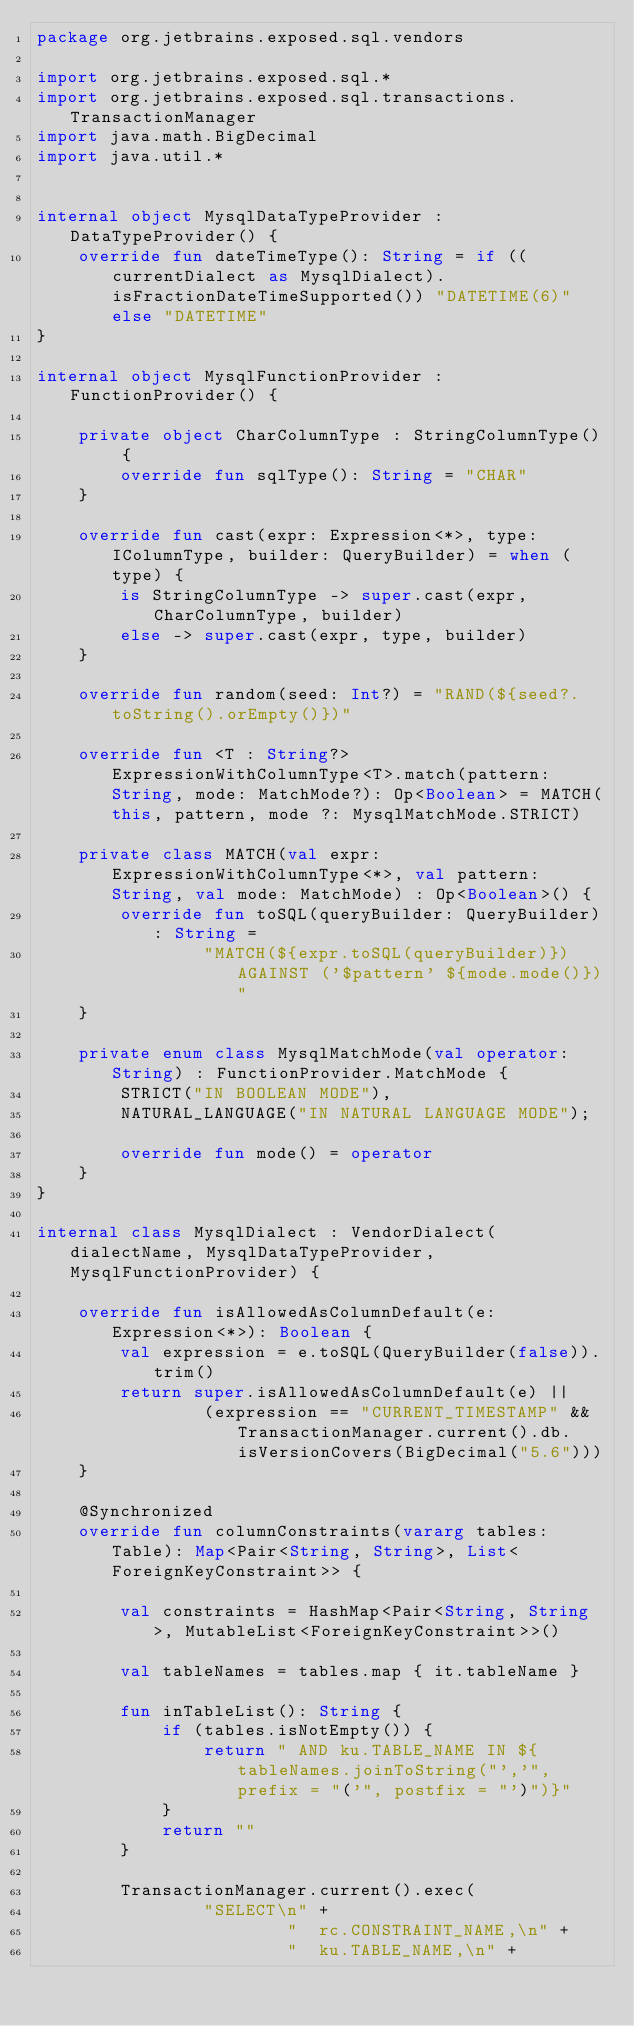<code> <loc_0><loc_0><loc_500><loc_500><_Kotlin_>package org.jetbrains.exposed.sql.vendors

import org.jetbrains.exposed.sql.*
import org.jetbrains.exposed.sql.transactions.TransactionManager
import java.math.BigDecimal
import java.util.*


internal object MysqlDataTypeProvider : DataTypeProvider() {
    override fun dateTimeType(): String = if ((currentDialect as MysqlDialect).isFractionDateTimeSupported()) "DATETIME(6)" else "DATETIME"
}

internal object MysqlFunctionProvider : FunctionProvider() {

    private object CharColumnType : StringColumnType() {
        override fun sqlType(): String = "CHAR"
    }

    override fun cast(expr: Expression<*>, type: IColumnType, builder: QueryBuilder) = when (type) {
        is StringColumnType -> super.cast(expr, CharColumnType, builder)
        else -> super.cast(expr, type, builder)
    }

    override fun random(seed: Int?) = "RAND(${seed?.toString().orEmpty()})"

    override fun <T : String?> ExpressionWithColumnType<T>.match(pattern: String, mode: MatchMode?): Op<Boolean> = MATCH(this, pattern, mode ?: MysqlMatchMode.STRICT)

    private class MATCH(val expr: ExpressionWithColumnType<*>, val pattern: String, val mode: MatchMode) : Op<Boolean>() {
        override fun toSQL(queryBuilder: QueryBuilder): String =
                "MATCH(${expr.toSQL(queryBuilder)}) AGAINST ('$pattern' ${mode.mode()})"
    }

    private enum class MysqlMatchMode(val operator: String) : FunctionProvider.MatchMode {
        STRICT("IN BOOLEAN MODE"),
        NATURAL_LANGUAGE("IN NATURAL LANGUAGE MODE");

        override fun mode() = operator
    }
}

internal class MysqlDialect : VendorDialect(dialectName, MysqlDataTypeProvider, MysqlFunctionProvider) {

    override fun isAllowedAsColumnDefault(e: Expression<*>): Boolean {
        val expression = e.toSQL(QueryBuilder(false)).trim()
        return super.isAllowedAsColumnDefault(e) ||
                (expression == "CURRENT_TIMESTAMP" && TransactionManager.current().db.isVersionCovers(BigDecimal("5.6")))
    }

    @Synchronized
    override fun columnConstraints(vararg tables: Table): Map<Pair<String, String>, List<ForeignKeyConstraint>> {

        val constraints = HashMap<Pair<String, String>, MutableList<ForeignKeyConstraint>>()

        val tableNames = tables.map { it.tableName }

        fun inTableList(): String {
            if (tables.isNotEmpty()) {
                return " AND ku.TABLE_NAME IN ${tableNames.joinToString("','", prefix = "('", postfix = "')")}"
            }
            return ""
        }

        TransactionManager.current().exec(
                "SELECT\n" +
                        "  rc.CONSTRAINT_NAME,\n" +
                        "  ku.TABLE_NAME,\n" +</code> 